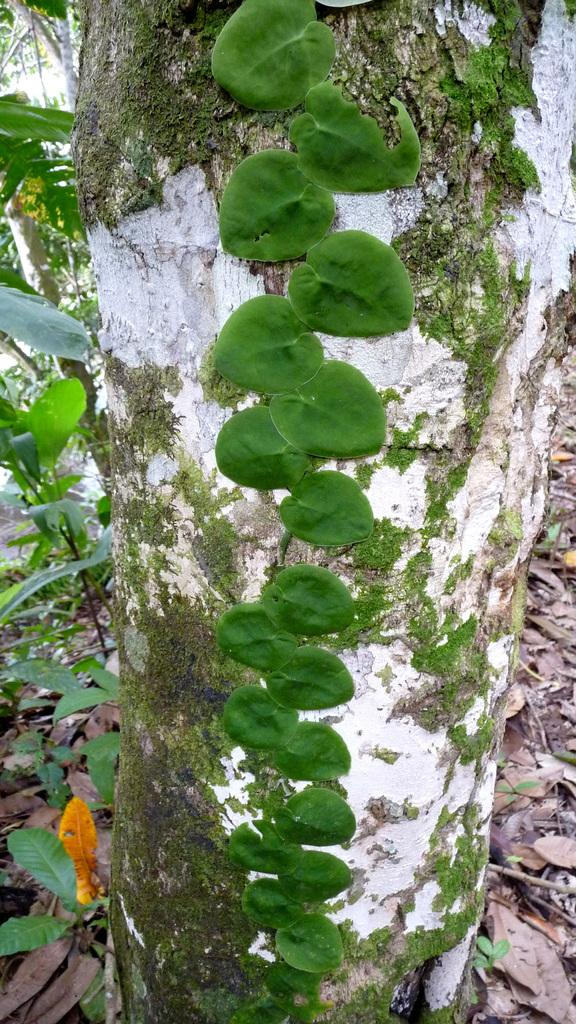What type of vegetation can be seen in the image? There are leaves in the image. What part of a tree is visible in the image? The stem of a tree is visible in the image. What is present at the bottom of the image? Dry leaves and twigs are present at the bottom of the image. What can be seen in the background of the image? There are trees in the background of the image. What type of crime is being committed in the image? There is no crime present in the image; it features leaves, a tree stem, dry leaves and twigs, and trees in the background. How many dolls are visible in the image? There are no dolls present in the image. 